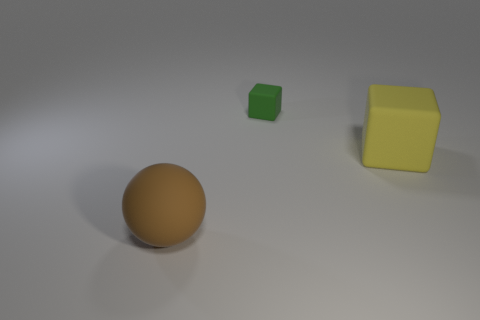Add 2 big yellow objects. How many objects exist? 5 Subtract all cubes. How many objects are left? 1 Add 3 big yellow rubber objects. How many big yellow rubber objects are left? 4 Add 2 large cubes. How many large cubes exist? 3 Subtract 0 blue cubes. How many objects are left? 3 Subtract all big yellow things. Subtract all yellow blocks. How many objects are left? 1 